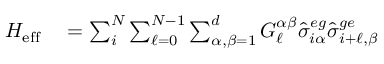Convert formula to latex. <formula><loc_0><loc_0><loc_500><loc_500>\begin{array} { r l } { H _ { e f f } } & = \sum _ { i } ^ { N } \sum _ { \ell = 0 } ^ { N - 1 } \sum _ { \alpha , \beta = 1 } ^ { d } G _ { \ell } ^ { \alpha \beta } \hat { \sigma } _ { i \alpha } ^ { e g } \hat { \sigma } _ { i + \ell , \beta } ^ { g e } } \end{array}</formula> 